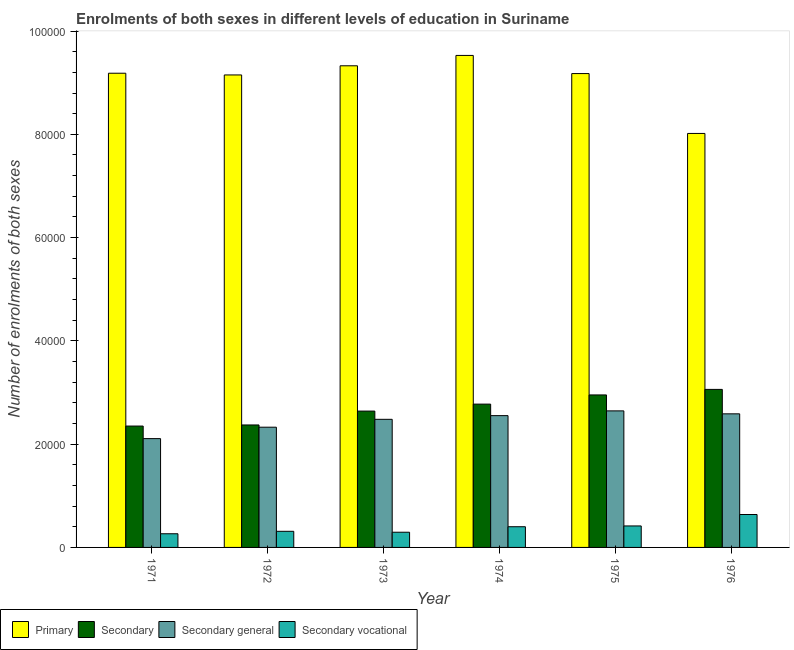How many different coloured bars are there?
Provide a short and direct response. 4. How many groups of bars are there?
Keep it short and to the point. 6. How many bars are there on the 2nd tick from the right?
Offer a terse response. 4. What is the label of the 6th group of bars from the left?
Your answer should be compact. 1976. What is the number of enrolments in secondary general education in 1974?
Make the answer very short. 2.55e+04. Across all years, what is the maximum number of enrolments in primary education?
Offer a very short reply. 9.53e+04. Across all years, what is the minimum number of enrolments in secondary vocational education?
Provide a short and direct response. 2646. In which year was the number of enrolments in secondary education maximum?
Your answer should be very brief. 1976. What is the total number of enrolments in secondary education in the graph?
Offer a very short reply. 1.62e+05. What is the difference between the number of enrolments in secondary general education in 1975 and that in 1976?
Ensure brevity in your answer.  570. What is the difference between the number of enrolments in secondary education in 1971 and the number of enrolments in secondary general education in 1972?
Ensure brevity in your answer.  -214. What is the average number of enrolments in secondary vocational education per year?
Your answer should be very brief. 3875.83. In how many years, is the number of enrolments in secondary education greater than 44000?
Offer a very short reply. 0. What is the ratio of the number of enrolments in secondary vocational education in 1975 to that in 1976?
Offer a terse response. 0.65. Is the number of enrolments in primary education in 1971 less than that in 1972?
Your response must be concise. No. What is the difference between the highest and the second highest number of enrolments in secondary education?
Your answer should be very brief. 1071. What is the difference between the highest and the lowest number of enrolments in secondary education?
Your answer should be compact. 7099. In how many years, is the number of enrolments in primary education greater than the average number of enrolments in primary education taken over all years?
Your answer should be very brief. 5. What does the 3rd bar from the left in 1976 represents?
Your answer should be very brief. Secondary general. What does the 4th bar from the right in 1975 represents?
Your response must be concise. Primary. Is it the case that in every year, the sum of the number of enrolments in primary education and number of enrolments in secondary education is greater than the number of enrolments in secondary general education?
Provide a short and direct response. Yes. Are all the bars in the graph horizontal?
Your answer should be compact. No. Does the graph contain grids?
Ensure brevity in your answer.  No. How are the legend labels stacked?
Ensure brevity in your answer.  Horizontal. What is the title of the graph?
Provide a succinct answer. Enrolments of both sexes in different levels of education in Suriname. Does "Taxes on income" appear as one of the legend labels in the graph?
Offer a very short reply. No. What is the label or title of the X-axis?
Provide a succinct answer. Year. What is the label or title of the Y-axis?
Your answer should be compact. Number of enrolments of both sexes. What is the Number of enrolments of both sexes of Primary in 1971?
Your answer should be very brief. 9.18e+04. What is the Number of enrolments of both sexes of Secondary in 1971?
Give a very brief answer. 2.35e+04. What is the Number of enrolments of both sexes in Secondary general in 1971?
Keep it short and to the point. 2.11e+04. What is the Number of enrolments of both sexes in Secondary vocational in 1971?
Offer a terse response. 2646. What is the Number of enrolments of both sexes of Primary in 1972?
Offer a very short reply. 9.15e+04. What is the Number of enrolments of both sexes in Secondary in 1972?
Your response must be concise. 2.37e+04. What is the Number of enrolments of both sexes in Secondary general in 1972?
Offer a terse response. 2.33e+04. What is the Number of enrolments of both sexes of Secondary vocational in 1972?
Provide a succinct answer. 3121. What is the Number of enrolments of both sexes in Primary in 1973?
Keep it short and to the point. 9.33e+04. What is the Number of enrolments of both sexes of Secondary in 1973?
Make the answer very short. 2.64e+04. What is the Number of enrolments of both sexes of Secondary general in 1973?
Ensure brevity in your answer.  2.48e+04. What is the Number of enrolments of both sexes of Secondary vocational in 1973?
Give a very brief answer. 2944. What is the Number of enrolments of both sexes in Primary in 1974?
Give a very brief answer. 9.53e+04. What is the Number of enrolments of both sexes of Secondary in 1974?
Make the answer very short. 2.78e+04. What is the Number of enrolments of both sexes in Secondary general in 1974?
Provide a succinct answer. 2.55e+04. What is the Number of enrolments of both sexes of Secondary vocational in 1974?
Provide a succinct answer. 4008. What is the Number of enrolments of both sexes in Primary in 1975?
Offer a very short reply. 9.18e+04. What is the Number of enrolments of both sexes of Secondary in 1975?
Provide a short and direct response. 2.95e+04. What is the Number of enrolments of both sexes of Secondary general in 1975?
Give a very brief answer. 2.64e+04. What is the Number of enrolments of both sexes of Secondary vocational in 1975?
Offer a very short reply. 4161. What is the Number of enrolments of both sexes of Primary in 1976?
Provide a succinct answer. 8.02e+04. What is the Number of enrolments of both sexes in Secondary in 1976?
Offer a terse response. 3.06e+04. What is the Number of enrolments of both sexes in Secondary general in 1976?
Give a very brief answer. 2.59e+04. What is the Number of enrolments of both sexes in Secondary vocational in 1976?
Keep it short and to the point. 6375. Across all years, what is the maximum Number of enrolments of both sexes in Primary?
Give a very brief answer. 9.53e+04. Across all years, what is the maximum Number of enrolments of both sexes in Secondary?
Make the answer very short. 3.06e+04. Across all years, what is the maximum Number of enrolments of both sexes in Secondary general?
Provide a short and direct response. 2.64e+04. Across all years, what is the maximum Number of enrolments of both sexes in Secondary vocational?
Give a very brief answer. 6375. Across all years, what is the minimum Number of enrolments of both sexes in Primary?
Provide a short and direct response. 8.02e+04. Across all years, what is the minimum Number of enrolments of both sexes in Secondary?
Your response must be concise. 2.35e+04. Across all years, what is the minimum Number of enrolments of both sexes in Secondary general?
Your answer should be very brief. 2.11e+04. Across all years, what is the minimum Number of enrolments of both sexes in Secondary vocational?
Keep it short and to the point. 2646. What is the total Number of enrolments of both sexes in Primary in the graph?
Give a very brief answer. 5.44e+05. What is the total Number of enrolments of both sexes of Secondary in the graph?
Offer a terse response. 1.62e+05. What is the total Number of enrolments of both sexes in Secondary general in the graph?
Offer a very short reply. 1.47e+05. What is the total Number of enrolments of both sexes of Secondary vocational in the graph?
Offer a terse response. 2.33e+04. What is the difference between the Number of enrolments of both sexes in Primary in 1971 and that in 1972?
Ensure brevity in your answer.  332. What is the difference between the Number of enrolments of both sexes in Secondary in 1971 and that in 1972?
Your answer should be compact. -214. What is the difference between the Number of enrolments of both sexes in Secondary general in 1971 and that in 1972?
Offer a very short reply. -2212. What is the difference between the Number of enrolments of both sexes in Secondary vocational in 1971 and that in 1972?
Your response must be concise. -475. What is the difference between the Number of enrolments of both sexes of Primary in 1971 and that in 1973?
Your answer should be very brief. -1441. What is the difference between the Number of enrolments of both sexes of Secondary in 1971 and that in 1973?
Your answer should be very brief. -2901. What is the difference between the Number of enrolments of both sexes of Secondary general in 1971 and that in 1973?
Provide a succinct answer. -3738. What is the difference between the Number of enrolments of both sexes of Secondary vocational in 1971 and that in 1973?
Make the answer very short. -298. What is the difference between the Number of enrolments of both sexes of Primary in 1971 and that in 1974?
Your answer should be compact. -3448. What is the difference between the Number of enrolments of both sexes of Secondary in 1971 and that in 1974?
Give a very brief answer. -4250. What is the difference between the Number of enrolments of both sexes in Secondary general in 1971 and that in 1974?
Offer a terse response. -4452. What is the difference between the Number of enrolments of both sexes of Secondary vocational in 1971 and that in 1974?
Provide a succinct answer. -1362. What is the difference between the Number of enrolments of both sexes of Secondary in 1971 and that in 1975?
Your answer should be compact. -6028. What is the difference between the Number of enrolments of both sexes of Secondary general in 1971 and that in 1975?
Give a very brief answer. -5370. What is the difference between the Number of enrolments of both sexes of Secondary vocational in 1971 and that in 1975?
Keep it short and to the point. -1515. What is the difference between the Number of enrolments of both sexes of Primary in 1971 and that in 1976?
Your answer should be very brief. 1.17e+04. What is the difference between the Number of enrolments of both sexes in Secondary in 1971 and that in 1976?
Offer a terse response. -7099. What is the difference between the Number of enrolments of both sexes in Secondary general in 1971 and that in 1976?
Ensure brevity in your answer.  -4800. What is the difference between the Number of enrolments of both sexes in Secondary vocational in 1971 and that in 1976?
Keep it short and to the point. -3729. What is the difference between the Number of enrolments of both sexes in Primary in 1972 and that in 1973?
Offer a very short reply. -1773. What is the difference between the Number of enrolments of both sexes of Secondary in 1972 and that in 1973?
Your answer should be very brief. -2687. What is the difference between the Number of enrolments of both sexes of Secondary general in 1972 and that in 1973?
Provide a short and direct response. -1526. What is the difference between the Number of enrolments of both sexes in Secondary vocational in 1972 and that in 1973?
Provide a succinct answer. 177. What is the difference between the Number of enrolments of both sexes of Primary in 1972 and that in 1974?
Your answer should be very brief. -3780. What is the difference between the Number of enrolments of both sexes in Secondary in 1972 and that in 1974?
Offer a very short reply. -4036. What is the difference between the Number of enrolments of both sexes in Secondary general in 1972 and that in 1974?
Your answer should be very brief. -2240. What is the difference between the Number of enrolments of both sexes in Secondary vocational in 1972 and that in 1974?
Provide a succinct answer. -887. What is the difference between the Number of enrolments of both sexes in Primary in 1972 and that in 1975?
Provide a succinct answer. -267. What is the difference between the Number of enrolments of both sexes in Secondary in 1972 and that in 1975?
Make the answer very short. -5814. What is the difference between the Number of enrolments of both sexes in Secondary general in 1972 and that in 1975?
Provide a succinct answer. -3158. What is the difference between the Number of enrolments of both sexes of Secondary vocational in 1972 and that in 1975?
Ensure brevity in your answer.  -1040. What is the difference between the Number of enrolments of both sexes of Primary in 1972 and that in 1976?
Your response must be concise. 1.13e+04. What is the difference between the Number of enrolments of both sexes in Secondary in 1972 and that in 1976?
Provide a succinct answer. -6885. What is the difference between the Number of enrolments of both sexes in Secondary general in 1972 and that in 1976?
Ensure brevity in your answer.  -2588. What is the difference between the Number of enrolments of both sexes in Secondary vocational in 1972 and that in 1976?
Your answer should be very brief. -3254. What is the difference between the Number of enrolments of both sexes of Primary in 1973 and that in 1974?
Your answer should be very brief. -2007. What is the difference between the Number of enrolments of both sexes in Secondary in 1973 and that in 1974?
Ensure brevity in your answer.  -1349. What is the difference between the Number of enrolments of both sexes of Secondary general in 1973 and that in 1974?
Your answer should be very brief. -714. What is the difference between the Number of enrolments of both sexes of Secondary vocational in 1973 and that in 1974?
Ensure brevity in your answer.  -1064. What is the difference between the Number of enrolments of both sexes in Primary in 1973 and that in 1975?
Your answer should be very brief. 1506. What is the difference between the Number of enrolments of both sexes in Secondary in 1973 and that in 1975?
Keep it short and to the point. -3127. What is the difference between the Number of enrolments of both sexes in Secondary general in 1973 and that in 1975?
Give a very brief answer. -1632. What is the difference between the Number of enrolments of both sexes of Secondary vocational in 1973 and that in 1975?
Your response must be concise. -1217. What is the difference between the Number of enrolments of both sexes of Primary in 1973 and that in 1976?
Keep it short and to the point. 1.31e+04. What is the difference between the Number of enrolments of both sexes in Secondary in 1973 and that in 1976?
Make the answer very short. -4198. What is the difference between the Number of enrolments of both sexes in Secondary general in 1973 and that in 1976?
Offer a very short reply. -1062. What is the difference between the Number of enrolments of both sexes of Secondary vocational in 1973 and that in 1976?
Your response must be concise. -3431. What is the difference between the Number of enrolments of both sexes in Primary in 1974 and that in 1975?
Your answer should be compact. 3513. What is the difference between the Number of enrolments of both sexes in Secondary in 1974 and that in 1975?
Your answer should be very brief. -1778. What is the difference between the Number of enrolments of both sexes in Secondary general in 1974 and that in 1975?
Provide a short and direct response. -918. What is the difference between the Number of enrolments of both sexes of Secondary vocational in 1974 and that in 1975?
Offer a very short reply. -153. What is the difference between the Number of enrolments of both sexes of Primary in 1974 and that in 1976?
Provide a succinct answer. 1.51e+04. What is the difference between the Number of enrolments of both sexes of Secondary in 1974 and that in 1976?
Provide a short and direct response. -2849. What is the difference between the Number of enrolments of both sexes of Secondary general in 1974 and that in 1976?
Make the answer very short. -348. What is the difference between the Number of enrolments of both sexes in Secondary vocational in 1974 and that in 1976?
Give a very brief answer. -2367. What is the difference between the Number of enrolments of both sexes in Primary in 1975 and that in 1976?
Make the answer very short. 1.16e+04. What is the difference between the Number of enrolments of both sexes of Secondary in 1975 and that in 1976?
Provide a short and direct response. -1071. What is the difference between the Number of enrolments of both sexes in Secondary general in 1975 and that in 1976?
Your answer should be compact. 570. What is the difference between the Number of enrolments of both sexes in Secondary vocational in 1975 and that in 1976?
Offer a terse response. -2214. What is the difference between the Number of enrolments of both sexes in Primary in 1971 and the Number of enrolments of both sexes in Secondary in 1972?
Your answer should be compact. 6.81e+04. What is the difference between the Number of enrolments of both sexes of Primary in 1971 and the Number of enrolments of both sexes of Secondary general in 1972?
Keep it short and to the point. 6.86e+04. What is the difference between the Number of enrolments of both sexes in Primary in 1971 and the Number of enrolments of both sexes in Secondary vocational in 1972?
Ensure brevity in your answer.  8.87e+04. What is the difference between the Number of enrolments of both sexes of Secondary in 1971 and the Number of enrolments of both sexes of Secondary general in 1972?
Your answer should be very brief. 220. What is the difference between the Number of enrolments of both sexes of Secondary in 1971 and the Number of enrolments of both sexes of Secondary vocational in 1972?
Provide a short and direct response. 2.04e+04. What is the difference between the Number of enrolments of both sexes in Secondary general in 1971 and the Number of enrolments of both sexes in Secondary vocational in 1972?
Give a very brief answer. 1.80e+04. What is the difference between the Number of enrolments of both sexes in Primary in 1971 and the Number of enrolments of both sexes in Secondary in 1973?
Your response must be concise. 6.54e+04. What is the difference between the Number of enrolments of both sexes of Primary in 1971 and the Number of enrolments of both sexes of Secondary general in 1973?
Give a very brief answer. 6.70e+04. What is the difference between the Number of enrolments of both sexes of Primary in 1971 and the Number of enrolments of both sexes of Secondary vocational in 1973?
Your answer should be very brief. 8.89e+04. What is the difference between the Number of enrolments of both sexes in Secondary in 1971 and the Number of enrolments of both sexes in Secondary general in 1973?
Give a very brief answer. -1306. What is the difference between the Number of enrolments of both sexes of Secondary in 1971 and the Number of enrolments of both sexes of Secondary vocational in 1973?
Offer a terse response. 2.06e+04. What is the difference between the Number of enrolments of both sexes in Secondary general in 1971 and the Number of enrolments of both sexes in Secondary vocational in 1973?
Your answer should be compact. 1.81e+04. What is the difference between the Number of enrolments of both sexes in Primary in 1971 and the Number of enrolments of both sexes in Secondary in 1974?
Offer a terse response. 6.41e+04. What is the difference between the Number of enrolments of both sexes in Primary in 1971 and the Number of enrolments of both sexes in Secondary general in 1974?
Keep it short and to the point. 6.63e+04. What is the difference between the Number of enrolments of both sexes of Primary in 1971 and the Number of enrolments of both sexes of Secondary vocational in 1974?
Give a very brief answer. 8.78e+04. What is the difference between the Number of enrolments of both sexes in Secondary in 1971 and the Number of enrolments of both sexes in Secondary general in 1974?
Ensure brevity in your answer.  -2020. What is the difference between the Number of enrolments of both sexes of Secondary in 1971 and the Number of enrolments of both sexes of Secondary vocational in 1974?
Make the answer very short. 1.95e+04. What is the difference between the Number of enrolments of both sexes of Secondary general in 1971 and the Number of enrolments of both sexes of Secondary vocational in 1974?
Your answer should be very brief. 1.71e+04. What is the difference between the Number of enrolments of both sexes in Primary in 1971 and the Number of enrolments of both sexes in Secondary in 1975?
Give a very brief answer. 6.23e+04. What is the difference between the Number of enrolments of both sexes in Primary in 1971 and the Number of enrolments of both sexes in Secondary general in 1975?
Provide a succinct answer. 6.54e+04. What is the difference between the Number of enrolments of both sexes of Primary in 1971 and the Number of enrolments of both sexes of Secondary vocational in 1975?
Give a very brief answer. 8.77e+04. What is the difference between the Number of enrolments of both sexes in Secondary in 1971 and the Number of enrolments of both sexes in Secondary general in 1975?
Offer a very short reply. -2938. What is the difference between the Number of enrolments of both sexes in Secondary in 1971 and the Number of enrolments of both sexes in Secondary vocational in 1975?
Provide a succinct answer. 1.93e+04. What is the difference between the Number of enrolments of both sexes of Secondary general in 1971 and the Number of enrolments of both sexes of Secondary vocational in 1975?
Your response must be concise. 1.69e+04. What is the difference between the Number of enrolments of both sexes in Primary in 1971 and the Number of enrolments of both sexes in Secondary in 1976?
Your response must be concise. 6.12e+04. What is the difference between the Number of enrolments of both sexes in Primary in 1971 and the Number of enrolments of both sexes in Secondary general in 1976?
Keep it short and to the point. 6.60e+04. What is the difference between the Number of enrolments of both sexes in Primary in 1971 and the Number of enrolments of both sexes in Secondary vocational in 1976?
Give a very brief answer. 8.55e+04. What is the difference between the Number of enrolments of both sexes in Secondary in 1971 and the Number of enrolments of both sexes in Secondary general in 1976?
Ensure brevity in your answer.  -2368. What is the difference between the Number of enrolments of both sexes of Secondary in 1971 and the Number of enrolments of both sexes of Secondary vocational in 1976?
Your response must be concise. 1.71e+04. What is the difference between the Number of enrolments of both sexes of Secondary general in 1971 and the Number of enrolments of both sexes of Secondary vocational in 1976?
Make the answer very short. 1.47e+04. What is the difference between the Number of enrolments of both sexes in Primary in 1972 and the Number of enrolments of both sexes in Secondary in 1973?
Offer a very short reply. 6.51e+04. What is the difference between the Number of enrolments of both sexes of Primary in 1972 and the Number of enrolments of both sexes of Secondary general in 1973?
Provide a short and direct response. 6.67e+04. What is the difference between the Number of enrolments of both sexes in Primary in 1972 and the Number of enrolments of both sexes in Secondary vocational in 1973?
Your answer should be very brief. 8.86e+04. What is the difference between the Number of enrolments of both sexes of Secondary in 1972 and the Number of enrolments of both sexes of Secondary general in 1973?
Ensure brevity in your answer.  -1092. What is the difference between the Number of enrolments of both sexes in Secondary in 1972 and the Number of enrolments of both sexes in Secondary vocational in 1973?
Provide a short and direct response. 2.08e+04. What is the difference between the Number of enrolments of both sexes of Secondary general in 1972 and the Number of enrolments of both sexes of Secondary vocational in 1973?
Make the answer very short. 2.03e+04. What is the difference between the Number of enrolments of both sexes in Primary in 1972 and the Number of enrolments of both sexes in Secondary in 1974?
Keep it short and to the point. 6.37e+04. What is the difference between the Number of enrolments of both sexes of Primary in 1972 and the Number of enrolments of both sexes of Secondary general in 1974?
Offer a very short reply. 6.60e+04. What is the difference between the Number of enrolments of both sexes of Primary in 1972 and the Number of enrolments of both sexes of Secondary vocational in 1974?
Ensure brevity in your answer.  8.75e+04. What is the difference between the Number of enrolments of both sexes of Secondary in 1972 and the Number of enrolments of both sexes of Secondary general in 1974?
Make the answer very short. -1806. What is the difference between the Number of enrolments of both sexes in Secondary in 1972 and the Number of enrolments of both sexes in Secondary vocational in 1974?
Keep it short and to the point. 1.97e+04. What is the difference between the Number of enrolments of both sexes in Secondary general in 1972 and the Number of enrolments of both sexes in Secondary vocational in 1974?
Offer a terse response. 1.93e+04. What is the difference between the Number of enrolments of both sexes of Primary in 1972 and the Number of enrolments of both sexes of Secondary in 1975?
Your answer should be very brief. 6.20e+04. What is the difference between the Number of enrolments of both sexes of Primary in 1972 and the Number of enrolments of both sexes of Secondary general in 1975?
Your response must be concise. 6.51e+04. What is the difference between the Number of enrolments of both sexes of Primary in 1972 and the Number of enrolments of both sexes of Secondary vocational in 1975?
Your response must be concise. 8.73e+04. What is the difference between the Number of enrolments of both sexes of Secondary in 1972 and the Number of enrolments of both sexes of Secondary general in 1975?
Keep it short and to the point. -2724. What is the difference between the Number of enrolments of both sexes of Secondary in 1972 and the Number of enrolments of both sexes of Secondary vocational in 1975?
Offer a very short reply. 1.96e+04. What is the difference between the Number of enrolments of both sexes in Secondary general in 1972 and the Number of enrolments of both sexes in Secondary vocational in 1975?
Ensure brevity in your answer.  1.91e+04. What is the difference between the Number of enrolments of both sexes of Primary in 1972 and the Number of enrolments of both sexes of Secondary in 1976?
Make the answer very short. 6.09e+04. What is the difference between the Number of enrolments of both sexes of Primary in 1972 and the Number of enrolments of both sexes of Secondary general in 1976?
Your response must be concise. 6.56e+04. What is the difference between the Number of enrolments of both sexes in Primary in 1972 and the Number of enrolments of both sexes in Secondary vocational in 1976?
Make the answer very short. 8.51e+04. What is the difference between the Number of enrolments of both sexes of Secondary in 1972 and the Number of enrolments of both sexes of Secondary general in 1976?
Offer a terse response. -2154. What is the difference between the Number of enrolments of both sexes in Secondary in 1972 and the Number of enrolments of both sexes in Secondary vocational in 1976?
Provide a short and direct response. 1.73e+04. What is the difference between the Number of enrolments of both sexes in Secondary general in 1972 and the Number of enrolments of both sexes in Secondary vocational in 1976?
Offer a terse response. 1.69e+04. What is the difference between the Number of enrolments of both sexes in Primary in 1973 and the Number of enrolments of both sexes in Secondary in 1974?
Your answer should be very brief. 6.55e+04. What is the difference between the Number of enrolments of both sexes in Primary in 1973 and the Number of enrolments of both sexes in Secondary general in 1974?
Keep it short and to the point. 6.78e+04. What is the difference between the Number of enrolments of both sexes in Primary in 1973 and the Number of enrolments of both sexes in Secondary vocational in 1974?
Offer a very short reply. 8.93e+04. What is the difference between the Number of enrolments of both sexes of Secondary in 1973 and the Number of enrolments of both sexes of Secondary general in 1974?
Your answer should be compact. 881. What is the difference between the Number of enrolments of both sexes in Secondary in 1973 and the Number of enrolments of both sexes in Secondary vocational in 1974?
Provide a short and direct response. 2.24e+04. What is the difference between the Number of enrolments of both sexes of Secondary general in 1973 and the Number of enrolments of both sexes of Secondary vocational in 1974?
Provide a short and direct response. 2.08e+04. What is the difference between the Number of enrolments of both sexes of Primary in 1973 and the Number of enrolments of both sexes of Secondary in 1975?
Provide a short and direct response. 6.37e+04. What is the difference between the Number of enrolments of both sexes of Primary in 1973 and the Number of enrolments of both sexes of Secondary general in 1975?
Your answer should be very brief. 6.68e+04. What is the difference between the Number of enrolments of both sexes of Primary in 1973 and the Number of enrolments of both sexes of Secondary vocational in 1975?
Provide a short and direct response. 8.91e+04. What is the difference between the Number of enrolments of both sexes in Secondary in 1973 and the Number of enrolments of both sexes in Secondary general in 1975?
Provide a succinct answer. -37. What is the difference between the Number of enrolments of both sexes of Secondary in 1973 and the Number of enrolments of both sexes of Secondary vocational in 1975?
Your answer should be very brief. 2.22e+04. What is the difference between the Number of enrolments of both sexes of Secondary general in 1973 and the Number of enrolments of both sexes of Secondary vocational in 1975?
Keep it short and to the point. 2.06e+04. What is the difference between the Number of enrolments of both sexes in Primary in 1973 and the Number of enrolments of both sexes in Secondary in 1976?
Offer a terse response. 6.27e+04. What is the difference between the Number of enrolments of both sexes of Primary in 1973 and the Number of enrolments of both sexes of Secondary general in 1976?
Your answer should be compact. 6.74e+04. What is the difference between the Number of enrolments of both sexes of Primary in 1973 and the Number of enrolments of both sexes of Secondary vocational in 1976?
Make the answer very short. 8.69e+04. What is the difference between the Number of enrolments of both sexes of Secondary in 1973 and the Number of enrolments of both sexes of Secondary general in 1976?
Provide a succinct answer. 533. What is the difference between the Number of enrolments of both sexes of Secondary in 1973 and the Number of enrolments of both sexes of Secondary vocational in 1976?
Your answer should be compact. 2.00e+04. What is the difference between the Number of enrolments of both sexes of Secondary general in 1973 and the Number of enrolments of both sexes of Secondary vocational in 1976?
Your answer should be compact. 1.84e+04. What is the difference between the Number of enrolments of both sexes of Primary in 1974 and the Number of enrolments of both sexes of Secondary in 1975?
Your response must be concise. 6.58e+04. What is the difference between the Number of enrolments of both sexes of Primary in 1974 and the Number of enrolments of both sexes of Secondary general in 1975?
Make the answer very short. 6.88e+04. What is the difference between the Number of enrolments of both sexes in Primary in 1974 and the Number of enrolments of both sexes in Secondary vocational in 1975?
Offer a terse response. 9.11e+04. What is the difference between the Number of enrolments of both sexes in Secondary in 1974 and the Number of enrolments of both sexes in Secondary general in 1975?
Provide a succinct answer. 1312. What is the difference between the Number of enrolments of both sexes in Secondary in 1974 and the Number of enrolments of both sexes in Secondary vocational in 1975?
Your answer should be very brief. 2.36e+04. What is the difference between the Number of enrolments of both sexes in Secondary general in 1974 and the Number of enrolments of both sexes in Secondary vocational in 1975?
Offer a very short reply. 2.14e+04. What is the difference between the Number of enrolments of both sexes in Primary in 1974 and the Number of enrolments of both sexes in Secondary in 1976?
Provide a succinct answer. 6.47e+04. What is the difference between the Number of enrolments of both sexes of Primary in 1974 and the Number of enrolments of both sexes of Secondary general in 1976?
Provide a succinct answer. 6.94e+04. What is the difference between the Number of enrolments of both sexes in Primary in 1974 and the Number of enrolments of both sexes in Secondary vocational in 1976?
Keep it short and to the point. 8.89e+04. What is the difference between the Number of enrolments of both sexes in Secondary in 1974 and the Number of enrolments of both sexes in Secondary general in 1976?
Make the answer very short. 1882. What is the difference between the Number of enrolments of both sexes in Secondary in 1974 and the Number of enrolments of both sexes in Secondary vocational in 1976?
Make the answer very short. 2.14e+04. What is the difference between the Number of enrolments of both sexes in Secondary general in 1974 and the Number of enrolments of both sexes in Secondary vocational in 1976?
Offer a very short reply. 1.91e+04. What is the difference between the Number of enrolments of both sexes of Primary in 1975 and the Number of enrolments of both sexes of Secondary in 1976?
Give a very brief answer. 6.12e+04. What is the difference between the Number of enrolments of both sexes of Primary in 1975 and the Number of enrolments of both sexes of Secondary general in 1976?
Give a very brief answer. 6.59e+04. What is the difference between the Number of enrolments of both sexes of Primary in 1975 and the Number of enrolments of both sexes of Secondary vocational in 1976?
Give a very brief answer. 8.54e+04. What is the difference between the Number of enrolments of both sexes in Secondary in 1975 and the Number of enrolments of both sexes in Secondary general in 1976?
Your answer should be compact. 3660. What is the difference between the Number of enrolments of both sexes of Secondary in 1975 and the Number of enrolments of both sexes of Secondary vocational in 1976?
Your answer should be very brief. 2.32e+04. What is the difference between the Number of enrolments of both sexes in Secondary general in 1975 and the Number of enrolments of both sexes in Secondary vocational in 1976?
Keep it short and to the point. 2.01e+04. What is the average Number of enrolments of both sexes of Primary per year?
Make the answer very short. 9.06e+04. What is the average Number of enrolments of both sexes of Secondary per year?
Ensure brevity in your answer.  2.69e+04. What is the average Number of enrolments of both sexes in Secondary general per year?
Give a very brief answer. 2.45e+04. What is the average Number of enrolments of both sexes in Secondary vocational per year?
Make the answer very short. 3875.83. In the year 1971, what is the difference between the Number of enrolments of both sexes in Primary and Number of enrolments of both sexes in Secondary?
Give a very brief answer. 6.83e+04. In the year 1971, what is the difference between the Number of enrolments of both sexes of Primary and Number of enrolments of both sexes of Secondary general?
Offer a terse response. 7.08e+04. In the year 1971, what is the difference between the Number of enrolments of both sexes in Primary and Number of enrolments of both sexes in Secondary vocational?
Keep it short and to the point. 8.92e+04. In the year 1971, what is the difference between the Number of enrolments of both sexes of Secondary and Number of enrolments of both sexes of Secondary general?
Provide a succinct answer. 2432. In the year 1971, what is the difference between the Number of enrolments of both sexes in Secondary and Number of enrolments of both sexes in Secondary vocational?
Ensure brevity in your answer.  2.09e+04. In the year 1971, what is the difference between the Number of enrolments of both sexes of Secondary general and Number of enrolments of both sexes of Secondary vocational?
Offer a very short reply. 1.84e+04. In the year 1972, what is the difference between the Number of enrolments of both sexes in Primary and Number of enrolments of both sexes in Secondary?
Keep it short and to the point. 6.78e+04. In the year 1972, what is the difference between the Number of enrolments of both sexes in Primary and Number of enrolments of both sexes in Secondary general?
Offer a very short reply. 6.82e+04. In the year 1972, what is the difference between the Number of enrolments of both sexes of Primary and Number of enrolments of both sexes of Secondary vocational?
Make the answer very short. 8.84e+04. In the year 1972, what is the difference between the Number of enrolments of both sexes in Secondary and Number of enrolments of both sexes in Secondary general?
Provide a short and direct response. 434. In the year 1972, what is the difference between the Number of enrolments of both sexes of Secondary and Number of enrolments of both sexes of Secondary vocational?
Provide a short and direct response. 2.06e+04. In the year 1972, what is the difference between the Number of enrolments of both sexes in Secondary general and Number of enrolments of both sexes in Secondary vocational?
Keep it short and to the point. 2.02e+04. In the year 1973, what is the difference between the Number of enrolments of both sexes of Primary and Number of enrolments of both sexes of Secondary?
Your answer should be compact. 6.69e+04. In the year 1973, what is the difference between the Number of enrolments of both sexes in Primary and Number of enrolments of both sexes in Secondary general?
Give a very brief answer. 6.85e+04. In the year 1973, what is the difference between the Number of enrolments of both sexes in Primary and Number of enrolments of both sexes in Secondary vocational?
Ensure brevity in your answer.  9.03e+04. In the year 1973, what is the difference between the Number of enrolments of both sexes of Secondary and Number of enrolments of both sexes of Secondary general?
Your answer should be very brief. 1595. In the year 1973, what is the difference between the Number of enrolments of both sexes in Secondary and Number of enrolments of both sexes in Secondary vocational?
Give a very brief answer. 2.35e+04. In the year 1973, what is the difference between the Number of enrolments of both sexes in Secondary general and Number of enrolments of both sexes in Secondary vocational?
Offer a terse response. 2.19e+04. In the year 1974, what is the difference between the Number of enrolments of both sexes of Primary and Number of enrolments of both sexes of Secondary?
Give a very brief answer. 6.75e+04. In the year 1974, what is the difference between the Number of enrolments of both sexes of Primary and Number of enrolments of both sexes of Secondary general?
Your response must be concise. 6.98e+04. In the year 1974, what is the difference between the Number of enrolments of both sexes of Primary and Number of enrolments of both sexes of Secondary vocational?
Keep it short and to the point. 9.13e+04. In the year 1974, what is the difference between the Number of enrolments of both sexes in Secondary and Number of enrolments of both sexes in Secondary general?
Offer a very short reply. 2230. In the year 1974, what is the difference between the Number of enrolments of both sexes of Secondary and Number of enrolments of both sexes of Secondary vocational?
Keep it short and to the point. 2.37e+04. In the year 1974, what is the difference between the Number of enrolments of both sexes in Secondary general and Number of enrolments of both sexes in Secondary vocational?
Provide a succinct answer. 2.15e+04. In the year 1975, what is the difference between the Number of enrolments of both sexes in Primary and Number of enrolments of both sexes in Secondary?
Give a very brief answer. 6.22e+04. In the year 1975, what is the difference between the Number of enrolments of both sexes of Primary and Number of enrolments of both sexes of Secondary general?
Give a very brief answer. 6.53e+04. In the year 1975, what is the difference between the Number of enrolments of both sexes of Primary and Number of enrolments of both sexes of Secondary vocational?
Your answer should be very brief. 8.76e+04. In the year 1975, what is the difference between the Number of enrolments of both sexes of Secondary and Number of enrolments of both sexes of Secondary general?
Provide a succinct answer. 3090. In the year 1975, what is the difference between the Number of enrolments of both sexes in Secondary and Number of enrolments of both sexes in Secondary vocational?
Your answer should be very brief. 2.54e+04. In the year 1975, what is the difference between the Number of enrolments of both sexes of Secondary general and Number of enrolments of both sexes of Secondary vocational?
Your response must be concise. 2.23e+04. In the year 1976, what is the difference between the Number of enrolments of both sexes of Primary and Number of enrolments of both sexes of Secondary?
Provide a short and direct response. 4.96e+04. In the year 1976, what is the difference between the Number of enrolments of both sexes of Primary and Number of enrolments of both sexes of Secondary general?
Offer a terse response. 5.43e+04. In the year 1976, what is the difference between the Number of enrolments of both sexes in Primary and Number of enrolments of both sexes in Secondary vocational?
Your answer should be compact. 7.38e+04. In the year 1976, what is the difference between the Number of enrolments of both sexes of Secondary and Number of enrolments of both sexes of Secondary general?
Keep it short and to the point. 4731. In the year 1976, what is the difference between the Number of enrolments of both sexes of Secondary and Number of enrolments of both sexes of Secondary vocational?
Make the answer very short. 2.42e+04. In the year 1976, what is the difference between the Number of enrolments of both sexes of Secondary general and Number of enrolments of both sexes of Secondary vocational?
Your answer should be very brief. 1.95e+04. What is the ratio of the Number of enrolments of both sexes of Primary in 1971 to that in 1972?
Offer a terse response. 1. What is the ratio of the Number of enrolments of both sexes of Secondary in 1971 to that in 1972?
Keep it short and to the point. 0.99. What is the ratio of the Number of enrolments of both sexes in Secondary general in 1971 to that in 1972?
Offer a terse response. 0.91. What is the ratio of the Number of enrolments of both sexes in Secondary vocational in 1971 to that in 1972?
Make the answer very short. 0.85. What is the ratio of the Number of enrolments of both sexes of Primary in 1971 to that in 1973?
Offer a terse response. 0.98. What is the ratio of the Number of enrolments of both sexes of Secondary in 1971 to that in 1973?
Ensure brevity in your answer.  0.89. What is the ratio of the Number of enrolments of both sexes in Secondary general in 1971 to that in 1973?
Offer a very short reply. 0.85. What is the ratio of the Number of enrolments of both sexes of Secondary vocational in 1971 to that in 1973?
Provide a short and direct response. 0.9. What is the ratio of the Number of enrolments of both sexes of Primary in 1971 to that in 1974?
Provide a short and direct response. 0.96. What is the ratio of the Number of enrolments of both sexes of Secondary in 1971 to that in 1974?
Give a very brief answer. 0.85. What is the ratio of the Number of enrolments of both sexes of Secondary general in 1971 to that in 1974?
Your response must be concise. 0.83. What is the ratio of the Number of enrolments of both sexes of Secondary vocational in 1971 to that in 1974?
Give a very brief answer. 0.66. What is the ratio of the Number of enrolments of both sexes in Secondary in 1971 to that in 1975?
Your response must be concise. 0.8. What is the ratio of the Number of enrolments of both sexes of Secondary general in 1971 to that in 1975?
Give a very brief answer. 0.8. What is the ratio of the Number of enrolments of both sexes of Secondary vocational in 1971 to that in 1975?
Offer a terse response. 0.64. What is the ratio of the Number of enrolments of both sexes in Primary in 1971 to that in 1976?
Give a very brief answer. 1.15. What is the ratio of the Number of enrolments of both sexes of Secondary in 1971 to that in 1976?
Ensure brevity in your answer.  0.77. What is the ratio of the Number of enrolments of both sexes in Secondary general in 1971 to that in 1976?
Keep it short and to the point. 0.81. What is the ratio of the Number of enrolments of both sexes of Secondary vocational in 1971 to that in 1976?
Provide a short and direct response. 0.42. What is the ratio of the Number of enrolments of both sexes in Secondary in 1972 to that in 1973?
Your answer should be very brief. 0.9. What is the ratio of the Number of enrolments of both sexes in Secondary general in 1972 to that in 1973?
Keep it short and to the point. 0.94. What is the ratio of the Number of enrolments of both sexes in Secondary vocational in 1972 to that in 1973?
Provide a succinct answer. 1.06. What is the ratio of the Number of enrolments of both sexes in Primary in 1972 to that in 1974?
Make the answer very short. 0.96. What is the ratio of the Number of enrolments of both sexes of Secondary in 1972 to that in 1974?
Ensure brevity in your answer.  0.85. What is the ratio of the Number of enrolments of both sexes of Secondary general in 1972 to that in 1974?
Your response must be concise. 0.91. What is the ratio of the Number of enrolments of both sexes in Secondary vocational in 1972 to that in 1974?
Offer a terse response. 0.78. What is the ratio of the Number of enrolments of both sexes of Secondary in 1972 to that in 1975?
Your answer should be compact. 0.8. What is the ratio of the Number of enrolments of both sexes in Secondary general in 1972 to that in 1975?
Keep it short and to the point. 0.88. What is the ratio of the Number of enrolments of both sexes in Secondary vocational in 1972 to that in 1975?
Your answer should be compact. 0.75. What is the ratio of the Number of enrolments of both sexes in Primary in 1972 to that in 1976?
Offer a terse response. 1.14. What is the ratio of the Number of enrolments of both sexes in Secondary in 1972 to that in 1976?
Provide a short and direct response. 0.78. What is the ratio of the Number of enrolments of both sexes of Secondary general in 1972 to that in 1976?
Make the answer very short. 0.9. What is the ratio of the Number of enrolments of both sexes of Secondary vocational in 1972 to that in 1976?
Offer a terse response. 0.49. What is the ratio of the Number of enrolments of both sexes of Primary in 1973 to that in 1974?
Your answer should be compact. 0.98. What is the ratio of the Number of enrolments of both sexes in Secondary in 1973 to that in 1974?
Offer a very short reply. 0.95. What is the ratio of the Number of enrolments of both sexes of Secondary general in 1973 to that in 1974?
Your answer should be very brief. 0.97. What is the ratio of the Number of enrolments of both sexes in Secondary vocational in 1973 to that in 1974?
Offer a very short reply. 0.73. What is the ratio of the Number of enrolments of both sexes of Primary in 1973 to that in 1975?
Your answer should be very brief. 1.02. What is the ratio of the Number of enrolments of both sexes of Secondary in 1973 to that in 1975?
Ensure brevity in your answer.  0.89. What is the ratio of the Number of enrolments of both sexes of Secondary general in 1973 to that in 1975?
Offer a terse response. 0.94. What is the ratio of the Number of enrolments of both sexes of Secondary vocational in 1973 to that in 1975?
Provide a succinct answer. 0.71. What is the ratio of the Number of enrolments of both sexes in Primary in 1973 to that in 1976?
Give a very brief answer. 1.16. What is the ratio of the Number of enrolments of both sexes of Secondary in 1973 to that in 1976?
Offer a very short reply. 0.86. What is the ratio of the Number of enrolments of both sexes in Secondary vocational in 1973 to that in 1976?
Your answer should be very brief. 0.46. What is the ratio of the Number of enrolments of both sexes of Primary in 1974 to that in 1975?
Make the answer very short. 1.04. What is the ratio of the Number of enrolments of both sexes in Secondary in 1974 to that in 1975?
Ensure brevity in your answer.  0.94. What is the ratio of the Number of enrolments of both sexes in Secondary general in 1974 to that in 1975?
Keep it short and to the point. 0.97. What is the ratio of the Number of enrolments of both sexes of Secondary vocational in 1974 to that in 1975?
Make the answer very short. 0.96. What is the ratio of the Number of enrolments of both sexes of Primary in 1974 to that in 1976?
Offer a terse response. 1.19. What is the ratio of the Number of enrolments of both sexes of Secondary in 1974 to that in 1976?
Provide a short and direct response. 0.91. What is the ratio of the Number of enrolments of both sexes in Secondary general in 1974 to that in 1976?
Your answer should be compact. 0.99. What is the ratio of the Number of enrolments of both sexes in Secondary vocational in 1974 to that in 1976?
Offer a terse response. 0.63. What is the ratio of the Number of enrolments of both sexes of Primary in 1975 to that in 1976?
Your response must be concise. 1.14. What is the ratio of the Number of enrolments of both sexes of Secondary general in 1975 to that in 1976?
Offer a terse response. 1.02. What is the ratio of the Number of enrolments of both sexes of Secondary vocational in 1975 to that in 1976?
Offer a very short reply. 0.65. What is the difference between the highest and the second highest Number of enrolments of both sexes in Primary?
Your response must be concise. 2007. What is the difference between the highest and the second highest Number of enrolments of both sexes of Secondary?
Keep it short and to the point. 1071. What is the difference between the highest and the second highest Number of enrolments of both sexes in Secondary general?
Your answer should be compact. 570. What is the difference between the highest and the second highest Number of enrolments of both sexes of Secondary vocational?
Provide a succinct answer. 2214. What is the difference between the highest and the lowest Number of enrolments of both sexes of Primary?
Provide a succinct answer. 1.51e+04. What is the difference between the highest and the lowest Number of enrolments of both sexes in Secondary?
Give a very brief answer. 7099. What is the difference between the highest and the lowest Number of enrolments of both sexes of Secondary general?
Your answer should be very brief. 5370. What is the difference between the highest and the lowest Number of enrolments of both sexes of Secondary vocational?
Give a very brief answer. 3729. 